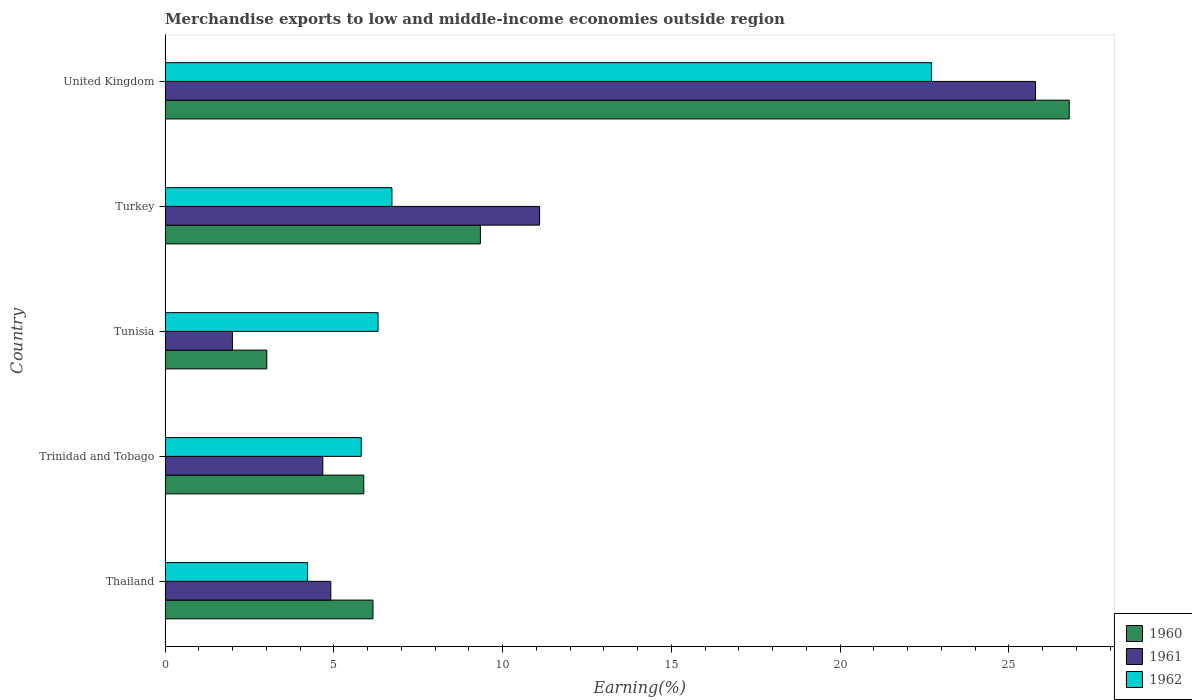Are the number of bars per tick equal to the number of legend labels?
Provide a short and direct response. Yes. Are the number of bars on each tick of the Y-axis equal?
Your answer should be very brief. Yes. How many bars are there on the 4th tick from the bottom?
Make the answer very short. 3. What is the label of the 1st group of bars from the top?
Provide a succinct answer. United Kingdom. What is the percentage of amount earned from merchandise exports in 1960 in Tunisia?
Provide a succinct answer. 3.01. Across all countries, what is the maximum percentage of amount earned from merchandise exports in 1962?
Keep it short and to the point. 22.71. Across all countries, what is the minimum percentage of amount earned from merchandise exports in 1960?
Ensure brevity in your answer.  3.01. In which country was the percentage of amount earned from merchandise exports in 1961 maximum?
Your response must be concise. United Kingdom. In which country was the percentage of amount earned from merchandise exports in 1962 minimum?
Ensure brevity in your answer.  Thailand. What is the total percentage of amount earned from merchandise exports in 1961 in the graph?
Your answer should be compact. 48.46. What is the difference between the percentage of amount earned from merchandise exports in 1960 in Thailand and that in Trinidad and Tobago?
Provide a short and direct response. 0.27. What is the difference between the percentage of amount earned from merchandise exports in 1960 in Thailand and the percentage of amount earned from merchandise exports in 1961 in Trinidad and Tobago?
Ensure brevity in your answer.  1.49. What is the average percentage of amount earned from merchandise exports in 1962 per country?
Your response must be concise. 9.15. What is the difference between the percentage of amount earned from merchandise exports in 1961 and percentage of amount earned from merchandise exports in 1960 in United Kingdom?
Provide a short and direct response. -1. What is the ratio of the percentage of amount earned from merchandise exports in 1962 in Thailand to that in Trinidad and Tobago?
Your answer should be compact. 0.73. What is the difference between the highest and the second highest percentage of amount earned from merchandise exports in 1961?
Your answer should be compact. 14.69. What is the difference between the highest and the lowest percentage of amount earned from merchandise exports in 1962?
Give a very brief answer. 18.49. Is the sum of the percentage of amount earned from merchandise exports in 1961 in Turkey and United Kingdom greater than the maximum percentage of amount earned from merchandise exports in 1962 across all countries?
Offer a terse response. Yes. How many bars are there?
Provide a succinct answer. 15. How many countries are there in the graph?
Offer a very short reply. 5. Does the graph contain any zero values?
Give a very brief answer. No. Does the graph contain grids?
Provide a short and direct response. No. Where does the legend appear in the graph?
Your answer should be very brief. Bottom right. How many legend labels are there?
Provide a short and direct response. 3. What is the title of the graph?
Offer a very short reply. Merchandise exports to low and middle-income economies outside region. What is the label or title of the X-axis?
Offer a terse response. Earning(%). What is the label or title of the Y-axis?
Your response must be concise. Country. What is the Earning(%) of 1960 in Thailand?
Provide a succinct answer. 6.16. What is the Earning(%) in 1961 in Thailand?
Provide a short and direct response. 4.91. What is the Earning(%) of 1962 in Thailand?
Provide a succinct answer. 4.22. What is the Earning(%) of 1960 in Trinidad and Tobago?
Make the answer very short. 5.89. What is the Earning(%) in 1961 in Trinidad and Tobago?
Keep it short and to the point. 4.67. What is the Earning(%) of 1962 in Trinidad and Tobago?
Offer a very short reply. 5.81. What is the Earning(%) of 1960 in Tunisia?
Give a very brief answer. 3.01. What is the Earning(%) in 1961 in Tunisia?
Make the answer very short. 1.99. What is the Earning(%) in 1962 in Tunisia?
Provide a short and direct response. 6.31. What is the Earning(%) in 1960 in Turkey?
Your answer should be compact. 9.34. What is the Earning(%) in 1961 in Turkey?
Offer a very short reply. 11.1. What is the Earning(%) in 1962 in Turkey?
Ensure brevity in your answer.  6.72. What is the Earning(%) in 1960 in United Kingdom?
Your response must be concise. 26.79. What is the Earning(%) of 1961 in United Kingdom?
Your answer should be very brief. 25.79. What is the Earning(%) of 1962 in United Kingdom?
Offer a very short reply. 22.71. Across all countries, what is the maximum Earning(%) in 1960?
Make the answer very short. 26.79. Across all countries, what is the maximum Earning(%) in 1961?
Offer a terse response. 25.79. Across all countries, what is the maximum Earning(%) of 1962?
Provide a succinct answer. 22.71. Across all countries, what is the minimum Earning(%) in 1960?
Your answer should be compact. 3.01. Across all countries, what is the minimum Earning(%) of 1961?
Ensure brevity in your answer.  1.99. Across all countries, what is the minimum Earning(%) of 1962?
Your answer should be compact. 4.22. What is the total Earning(%) of 1960 in the graph?
Your response must be concise. 51.19. What is the total Earning(%) of 1961 in the graph?
Ensure brevity in your answer.  48.46. What is the total Earning(%) of 1962 in the graph?
Give a very brief answer. 45.77. What is the difference between the Earning(%) of 1960 in Thailand and that in Trinidad and Tobago?
Provide a succinct answer. 0.27. What is the difference between the Earning(%) in 1961 in Thailand and that in Trinidad and Tobago?
Your answer should be compact. 0.24. What is the difference between the Earning(%) of 1962 in Thailand and that in Trinidad and Tobago?
Provide a short and direct response. -1.59. What is the difference between the Earning(%) in 1960 in Thailand and that in Tunisia?
Offer a terse response. 3.15. What is the difference between the Earning(%) of 1961 in Thailand and that in Tunisia?
Ensure brevity in your answer.  2.92. What is the difference between the Earning(%) in 1962 in Thailand and that in Tunisia?
Offer a terse response. -2.09. What is the difference between the Earning(%) of 1960 in Thailand and that in Turkey?
Give a very brief answer. -3.18. What is the difference between the Earning(%) in 1961 in Thailand and that in Turkey?
Provide a succinct answer. -6.19. What is the difference between the Earning(%) of 1962 in Thailand and that in Turkey?
Ensure brevity in your answer.  -2.5. What is the difference between the Earning(%) of 1960 in Thailand and that in United Kingdom?
Your response must be concise. -20.63. What is the difference between the Earning(%) in 1961 in Thailand and that in United Kingdom?
Provide a short and direct response. -20.88. What is the difference between the Earning(%) in 1962 in Thailand and that in United Kingdom?
Your answer should be compact. -18.49. What is the difference between the Earning(%) of 1960 in Trinidad and Tobago and that in Tunisia?
Your response must be concise. 2.87. What is the difference between the Earning(%) of 1961 in Trinidad and Tobago and that in Tunisia?
Offer a very short reply. 2.68. What is the difference between the Earning(%) of 1962 in Trinidad and Tobago and that in Tunisia?
Your answer should be compact. -0.5. What is the difference between the Earning(%) in 1960 in Trinidad and Tobago and that in Turkey?
Ensure brevity in your answer.  -3.46. What is the difference between the Earning(%) in 1961 in Trinidad and Tobago and that in Turkey?
Provide a short and direct response. -6.42. What is the difference between the Earning(%) in 1962 in Trinidad and Tobago and that in Turkey?
Offer a very short reply. -0.91. What is the difference between the Earning(%) of 1960 in Trinidad and Tobago and that in United Kingdom?
Offer a terse response. -20.9. What is the difference between the Earning(%) of 1961 in Trinidad and Tobago and that in United Kingdom?
Offer a terse response. -21.11. What is the difference between the Earning(%) of 1962 in Trinidad and Tobago and that in United Kingdom?
Give a very brief answer. -16.89. What is the difference between the Earning(%) of 1960 in Tunisia and that in Turkey?
Keep it short and to the point. -6.33. What is the difference between the Earning(%) in 1961 in Tunisia and that in Turkey?
Offer a terse response. -9.1. What is the difference between the Earning(%) in 1962 in Tunisia and that in Turkey?
Keep it short and to the point. -0.41. What is the difference between the Earning(%) of 1960 in Tunisia and that in United Kingdom?
Offer a very short reply. -23.77. What is the difference between the Earning(%) of 1961 in Tunisia and that in United Kingdom?
Your response must be concise. -23.79. What is the difference between the Earning(%) of 1962 in Tunisia and that in United Kingdom?
Keep it short and to the point. -16.4. What is the difference between the Earning(%) of 1960 in Turkey and that in United Kingdom?
Your answer should be very brief. -17.45. What is the difference between the Earning(%) of 1961 in Turkey and that in United Kingdom?
Your answer should be compact. -14.69. What is the difference between the Earning(%) of 1962 in Turkey and that in United Kingdom?
Give a very brief answer. -15.99. What is the difference between the Earning(%) in 1960 in Thailand and the Earning(%) in 1961 in Trinidad and Tobago?
Your answer should be very brief. 1.49. What is the difference between the Earning(%) of 1960 in Thailand and the Earning(%) of 1962 in Trinidad and Tobago?
Your answer should be compact. 0.35. What is the difference between the Earning(%) in 1961 in Thailand and the Earning(%) in 1962 in Trinidad and Tobago?
Your answer should be compact. -0.9. What is the difference between the Earning(%) in 1960 in Thailand and the Earning(%) in 1961 in Tunisia?
Provide a succinct answer. 4.16. What is the difference between the Earning(%) of 1960 in Thailand and the Earning(%) of 1962 in Tunisia?
Ensure brevity in your answer.  -0.15. What is the difference between the Earning(%) in 1961 in Thailand and the Earning(%) in 1962 in Tunisia?
Provide a short and direct response. -1.4. What is the difference between the Earning(%) in 1960 in Thailand and the Earning(%) in 1961 in Turkey?
Your response must be concise. -4.94. What is the difference between the Earning(%) in 1960 in Thailand and the Earning(%) in 1962 in Turkey?
Ensure brevity in your answer.  -0.56. What is the difference between the Earning(%) of 1961 in Thailand and the Earning(%) of 1962 in Turkey?
Your response must be concise. -1.81. What is the difference between the Earning(%) of 1960 in Thailand and the Earning(%) of 1961 in United Kingdom?
Your answer should be compact. -19.63. What is the difference between the Earning(%) of 1960 in Thailand and the Earning(%) of 1962 in United Kingdom?
Offer a very short reply. -16.55. What is the difference between the Earning(%) in 1961 in Thailand and the Earning(%) in 1962 in United Kingdom?
Provide a short and direct response. -17.8. What is the difference between the Earning(%) of 1960 in Trinidad and Tobago and the Earning(%) of 1961 in Tunisia?
Provide a succinct answer. 3.89. What is the difference between the Earning(%) of 1960 in Trinidad and Tobago and the Earning(%) of 1962 in Tunisia?
Provide a short and direct response. -0.42. What is the difference between the Earning(%) of 1961 in Trinidad and Tobago and the Earning(%) of 1962 in Tunisia?
Offer a terse response. -1.64. What is the difference between the Earning(%) of 1960 in Trinidad and Tobago and the Earning(%) of 1961 in Turkey?
Ensure brevity in your answer.  -5.21. What is the difference between the Earning(%) of 1960 in Trinidad and Tobago and the Earning(%) of 1962 in Turkey?
Ensure brevity in your answer.  -0.83. What is the difference between the Earning(%) of 1961 in Trinidad and Tobago and the Earning(%) of 1962 in Turkey?
Keep it short and to the point. -2.05. What is the difference between the Earning(%) in 1960 in Trinidad and Tobago and the Earning(%) in 1961 in United Kingdom?
Provide a short and direct response. -19.9. What is the difference between the Earning(%) in 1960 in Trinidad and Tobago and the Earning(%) in 1962 in United Kingdom?
Provide a short and direct response. -16.82. What is the difference between the Earning(%) in 1961 in Trinidad and Tobago and the Earning(%) in 1962 in United Kingdom?
Give a very brief answer. -18.03. What is the difference between the Earning(%) of 1960 in Tunisia and the Earning(%) of 1961 in Turkey?
Offer a very short reply. -8.08. What is the difference between the Earning(%) in 1960 in Tunisia and the Earning(%) in 1962 in Turkey?
Offer a terse response. -3.71. What is the difference between the Earning(%) of 1961 in Tunisia and the Earning(%) of 1962 in Turkey?
Your answer should be very brief. -4.73. What is the difference between the Earning(%) of 1960 in Tunisia and the Earning(%) of 1961 in United Kingdom?
Keep it short and to the point. -22.78. What is the difference between the Earning(%) of 1960 in Tunisia and the Earning(%) of 1962 in United Kingdom?
Your answer should be compact. -19.69. What is the difference between the Earning(%) in 1961 in Tunisia and the Earning(%) in 1962 in United Kingdom?
Your response must be concise. -20.71. What is the difference between the Earning(%) of 1960 in Turkey and the Earning(%) of 1961 in United Kingdom?
Offer a terse response. -16.45. What is the difference between the Earning(%) of 1960 in Turkey and the Earning(%) of 1962 in United Kingdom?
Your answer should be very brief. -13.36. What is the difference between the Earning(%) in 1961 in Turkey and the Earning(%) in 1962 in United Kingdom?
Your answer should be compact. -11.61. What is the average Earning(%) of 1960 per country?
Make the answer very short. 10.24. What is the average Earning(%) in 1961 per country?
Provide a short and direct response. 9.69. What is the average Earning(%) of 1962 per country?
Your response must be concise. 9.15. What is the difference between the Earning(%) in 1960 and Earning(%) in 1961 in Thailand?
Your response must be concise. 1.25. What is the difference between the Earning(%) in 1960 and Earning(%) in 1962 in Thailand?
Keep it short and to the point. 1.94. What is the difference between the Earning(%) of 1961 and Earning(%) of 1962 in Thailand?
Provide a succinct answer. 0.69. What is the difference between the Earning(%) of 1960 and Earning(%) of 1961 in Trinidad and Tobago?
Your answer should be compact. 1.21. What is the difference between the Earning(%) in 1960 and Earning(%) in 1962 in Trinidad and Tobago?
Keep it short and to the point. 0.07. What is the difference between the Earning(%) of 1961 and Earning(%) of 1962 in Trinidad and Tobago?
Keep it short and to the point. -1.14. What is the difference between the Earning(%) of 1960 and Earning(%) of 1961 in Tunisia?
Make the answer very short. 1.02. What is the difference between the Earning(%) of 1960 and Earning(%) of 1962 in Tunisia?
Provide a short and direct response. -3.3. What is the difference between the Earning(%) in 1961 and Earning(%) in 1962 in Tunisia?
Keep it short and to the point. -4.31. What is the difference between the Earning(%) in 1960 and Earning(%) in 1961 in Turkey?
Give a very brief answer. -1.75. What is the difference between the Earning(%) in 1960 and Earning(%) in 1962 in Turkey?
Give a very brief answer. 2.62. What is the difference between the Earning(%) in 1961 and Earning(%) in 1962 in Turkey?
Provide a succinct answer. 4.37. What is the difference between the Earning(%) of 1960 and Earning(%) of 1962 in United Kingdom?
Your response must be concise. 4.08. What is the difference between the Earning(%) of 1961 and Earning(%) of 1962 in United Kingdom?
Offer a terse response. 3.08. What is the ratio of the Earning(%) of 1960 in Thailand to that in Trinidad and Tobago?
Provide a short and direct response. 1.05. What is the ratio of the Earning(%) in 1961 in Thailand to that in Trinidad and Tobago?
Offer a terse response. 1.05. What is the ratio of the Earning(%) in 1962 in Thailand to that in Trinidad and Tobago?
Make the answer very short. 0.73. What is the ratio of the Earning(%) of 1960 in Thailand to that in Tunisia?
Keep it short and to the point. 2.04. What is the ratio of the Earning(%) in 1961 in Thailand to that in Tunisia?
Your answer should be compact. 2.46. What is the ratio of the Earning(%) of 1962 in Thailand to that in Tunisia?
Your response must be concise. 0.67. What is the ratio of the Earning(%) in 1960 in Thailand to that in Turkey?
Keep it short and to the point. 0.66. What is the ratio of the Earning(%) in 1961 in Thailand to that in Turkey?
Offer a terse response. 0.44. What is the ratio of the Earning(%) in 1962 in Thailand to that in Turkey?
Your answer should be very brief. 0.63. What is the ratio of the Earning(%) in 1960 in Thailand to that in United Kingdom?
Make the answer very short. 0.23. What is the ratio of the Earning(%) of 1961 in Thailand to that in United Kingdom?
Provide a short and direct response. 0.19. What is the ratio of the Earning(%) of 1962 in Thailand to that in United Kingdom?
Offer a terse response. 0.19. What is the ratio of the Earning(%) of 1960 in Trinidad and Tobago to that in Tunisia?
Your answer should be compact. 1.95. What is the ratio of the Earning(%) in 1961 in Trinidad and Tobago to that in Tunisia?
Provide a succinct answer. 2.34. What is the ratio of the Earning(%) of 1962 in Trinidad and Tobago to that in Tunisia?
Offer a terse response. 0.92. What is the ratio of the Earning(%) in 1960 in Trinidad and Tobago to that in Turkey?
Offer a terse response. 0.63. What is the ratio of the Earning(%) of 1961 in Trinidad and Tobago to that in Turkey?
Offer a very short reply. 0.42. What is the ratio of the Earning(%) of 1962 in Trinidad and Tobago to that in Turkey?
Your answer should be very brief. 0.86. What is the ratio of the Earning(%) in 1960 in Trinidad and Tobago to that in United Kingdom?
Provide a short and direct response. 0.22. What is the ratio of the Earning(%) in 1961 in Trinidad and Tobago to that in United Kingdom?
Your answer should be compact. 0.18. What is the ratio of the Earning(%) of 1962 in Trinidad and Tobago to that in United Kingdom?
Make the answer very short. 0.26. What is the ratio of the Earning(%) of 1960 in Tunisia to that in Turkey?
Your answer should be compact. 0.32. What is the ratio of the Earning(%) in 1961 in Tunisia to that in Turkey?
Your answer should be very brief. 0.18. What is the ratio of the Earning(%) of 1962 in Tunisia to that in Turkey?
Your response must be concise. 0.94. What is the ratio of the Earning(%) of 1960 in Tunisia to that in United Kingdom?
Your answer should be compact. 0.11. What is the ratio of the Earning(%) in 1961 in Tunisia to that in United Kingdom?
Provide a succinct answer. 0.08. What is the ratio of the Earning(%) of 1962 in Tunisia to that in United Kingdom?
Give a very brief answer. 0.28. What is the ratio of the Earning(%) in 1960 in Turkey to that in United Kingdom?
Give a very brief answer. 0.35. What is the ratio of the Earning(%) in 1961 in Turkey to that in United Kingdom?
Offer a terse response. 0.43. What is the ratio of the Earning(%) in 1962 in Turkey to that in United Kingdom?
Your answer should be very brief. 0.3. What is the difference between the highest and the second highest Earning(%) in 1960?
Ensure brevity in your answer.  17.45. What is the difference between the highest and the second highest Earning(%) of 1961?
Keep it short and to the point. 14.69. What is the difference between the highest and the second highest Earning(%) of 1962?
Your answer should be compact. 15.99. What is the difference between the highest and the lowest Earning(%) in 1960?
Your response must be concise. 23.77. What is the difference between the highest and the lowest Earning(%) in 1961?
Ensure brevity in your answer.  23.79. What is the difference between the highest and the lowest Earning(%) of 1962?
Offer a very short reply. 18.49. 